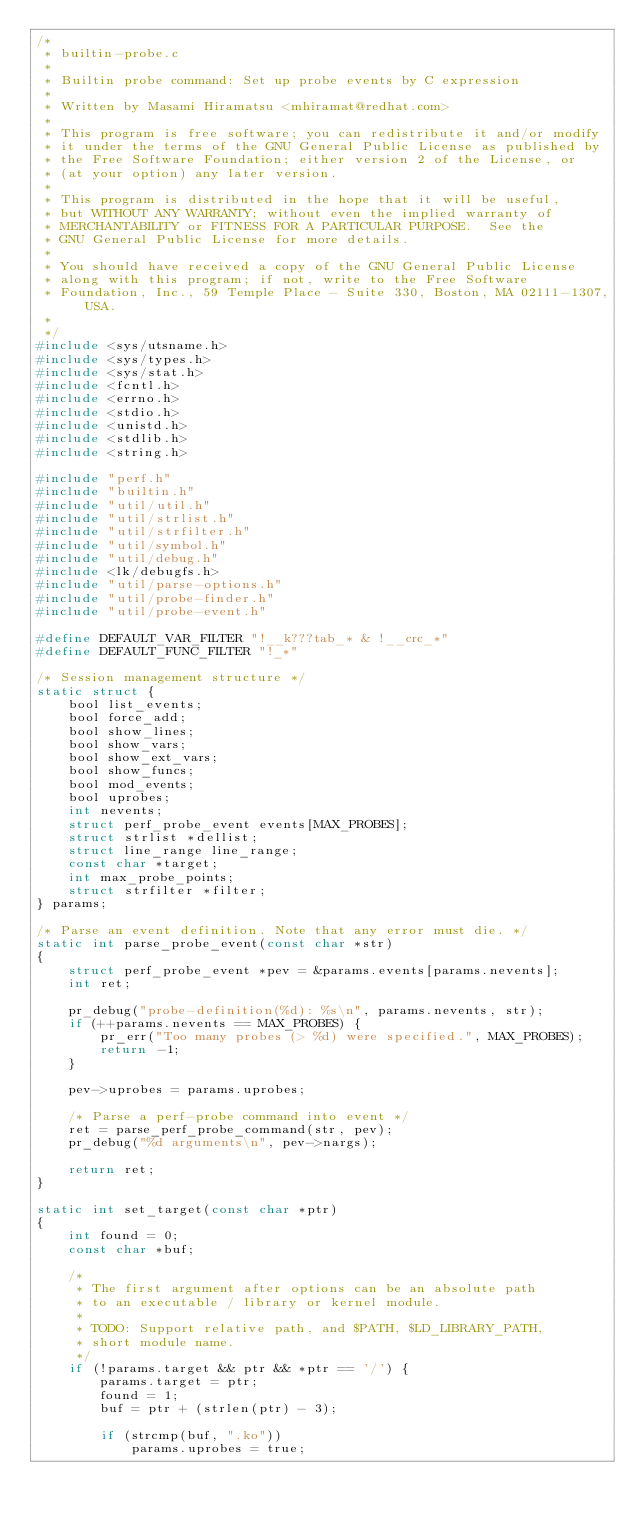<code> <loc_0><loc_0><loc_500><loc_500><_C_>/*
 * builtin-probe.c
 *
 * Builtin probe command: Set up probe events by C expression
 *
 * Written by Masami Hiramatsu <mhiramat@redhat.com>
 *
 * This program is free software; you can redistribute it and/or modify
 * it under the terms of the GNU General Public License as published by
 * the Free Software Foundation; either version 2 of the License, or
 * (at your option) any later version.
 *
 * This program is distributed in the hope that it will be useful,
 * but WITHOUT ANY WARRANTY; without even the implied warranty of
 * MERCHANTABILITY or FITNESS FOR A PARTICULAR PURPOSE.  See the
 * GNU General Public License for more details.
 *
 * You should have received a copy of the GNU General Public License
 * along with this program; if not, write to the Free Software
 * Foundation, Inc., 59 Temple Place - Suite 330, Boston, MA 02111-1307, USA.
 *
 */
#include <sys/utsname.h>
#include <sys/types.h>
#include <sys/stat.h>
#include <fcntl.h>
#include <errno.h>
#include <stdio.h>
#include <unistd.h>
#include <stdlib.h>
#include <string.h>

#include "perf.h"
#include "builtin.h"
#include "util/util.h"
#include "util/strlist.h"
#include "util/strfilter.h"
#include "util/symbol.h"
#include "util/debug.h"
#include <lk/debugfs.h>
#include "util/parse-options.h"
#include "util/probe-finder.h"
#include "util/probe-event.h"

#define DEFAULT_VAR_FILTER "!__k???tab_* & !__crc_*"
#define DEFAULT_FUNC_FILTER "!_*"

/* Session management structure */
static struct {
	bool list_events;
	bool force_add;
	bool show_lines;
	bool show_vars;
	bool show_ext_vars;
	bool show_funcs;
	bool mod_events;
	bool uprobes;
	int nevents;
	struct perf_probe_event events[MAX_PROBES];
	struct strlist *dellist;
	struct line_range line_range;
	const char *target;
	int max_probe_points;
	struct strfilter *filter;
} params;

/* Parse an event definition. Note that any error must die. */
static int parse_probe_event(const char *str)
{
	struct perf_probe_event *pev = &params.events[params.nevents];
	int ret;

	pr_debug("probe-definition(%d): %s\n", params.nevents, str);
	if (++params.nevents == MAX_PROBES) {
		pr_err("Too many probes (> %d) were specified.", MAX_PROBES);
		return -1;
	}

	pev->uprobes = params.uprobes;

	/* Parse a perf-probe command into event */
	ret = parse_perf_probe_command(str, pev);
	pr_debug("%d arguments\n", pev->nargs);

	return ret;
}

static int set_target(const char *ptr)
{
	int found = 0;
	const char *buf;

	/*
	 * The first argument after options can be an absolute path
	 * to an executable / library or kernel module.
	 *
	 * TODO: Support relative path, and $PATH, $LD_LIBRARY_PATH,
	 * short module name.
	 */
	if (!params.target && ptr && *ptr == '/') {
		params.target = ptr;
		found = 1;
		buf = ptr + (strlen(ptr) - 3);

		if (strcmp(buf, ".ko"))
			params.uprobes = true;
</code> 